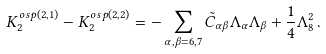Convert formula to latex. <formula><loc_0><loc_0><loc_500><loc_500>K _ { 2 } ^ { o s p ( 2 , 1 ) } - K _ { 2 } ^ { o s p ( 2 , 2 ) } = - \sum _ { \alpha , \beta = 6 , 7 } \tilde { C } _ { \alpha \beta } \Lambda _ { \alpha } \Lambda _ { \beta } + \frac { 1 } { 4 } \Lambda _ { 8 } ^ { 2 } \, .</formula> 